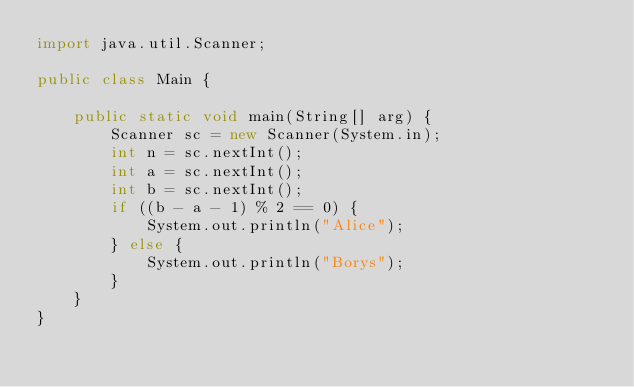Convert code to text. <code><loc_0><loc_0><loc_500><loc_500><_Java_>import java.util.Scanner;

public class Main {

    public static void main(String[] arg) {
        Scanner sc = new Scanner(System.in);
        int n = sc.nextInt();
        int a = sc.nextInt();
        int b = sc.nextInt();
        if ((b - a - 1) % 2 == 0) {
            System.out.println("Alice");
        } else {
            System.out.println("Borys");
        }
    }
}</code> 